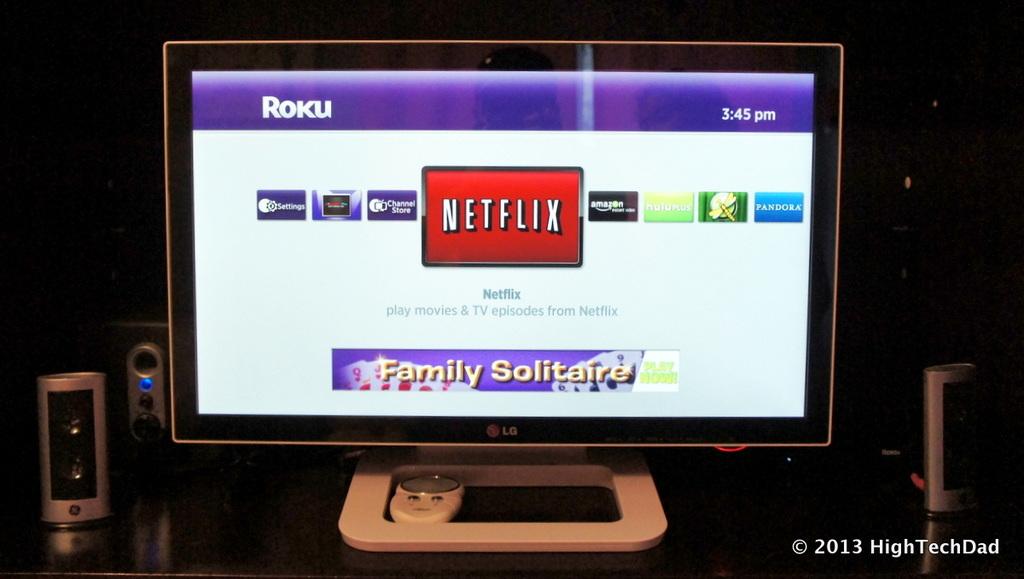What time is it in the afternoon?
Offer a terse response. 3:45 pm. What is the brand shown in the center of the tv?
Offer a very short reply. Netflix. 